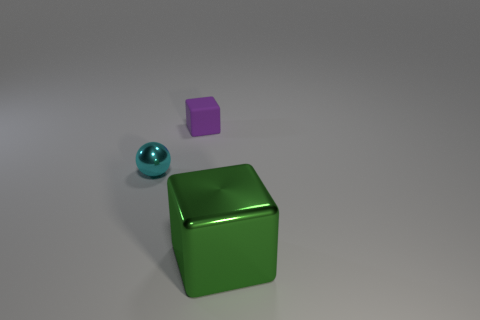There is a purple thing that is the same size as the cyan thing; what is its material?
Provide a succinct answer. Rubber. What number of metal objects are big green blocks or small cyan things?
Your answer should be very brief. 2. The thing that is on the left side of the large shiny thing and in front of the small rubber thing is what color?
Ensure brevity in your answer.  Cyan. There is a small cyan object; how many metal balls are in front of it?
Offer a very short reply. 0. What is the green block made of?
Provide a succinct answer. Metal. What color is the tiny object that is in front of the cube behind the small thing that is in front of the matte object?
Your answer should be compact. Cyan. What number of rubber blocks are the same size as the cyan sphere?
Keep it short and to the point. 1. The thing that is behind the tiny cyan metal sphere is what color?
Offer a terse response. Purple. How many other objects are there of the same size as the shiny block?
Make the answer very short. 0. What size is the thing that is both in front of the purple matte block and to the right of the tiny cyan sphere?
Offer a terse response. Large. 